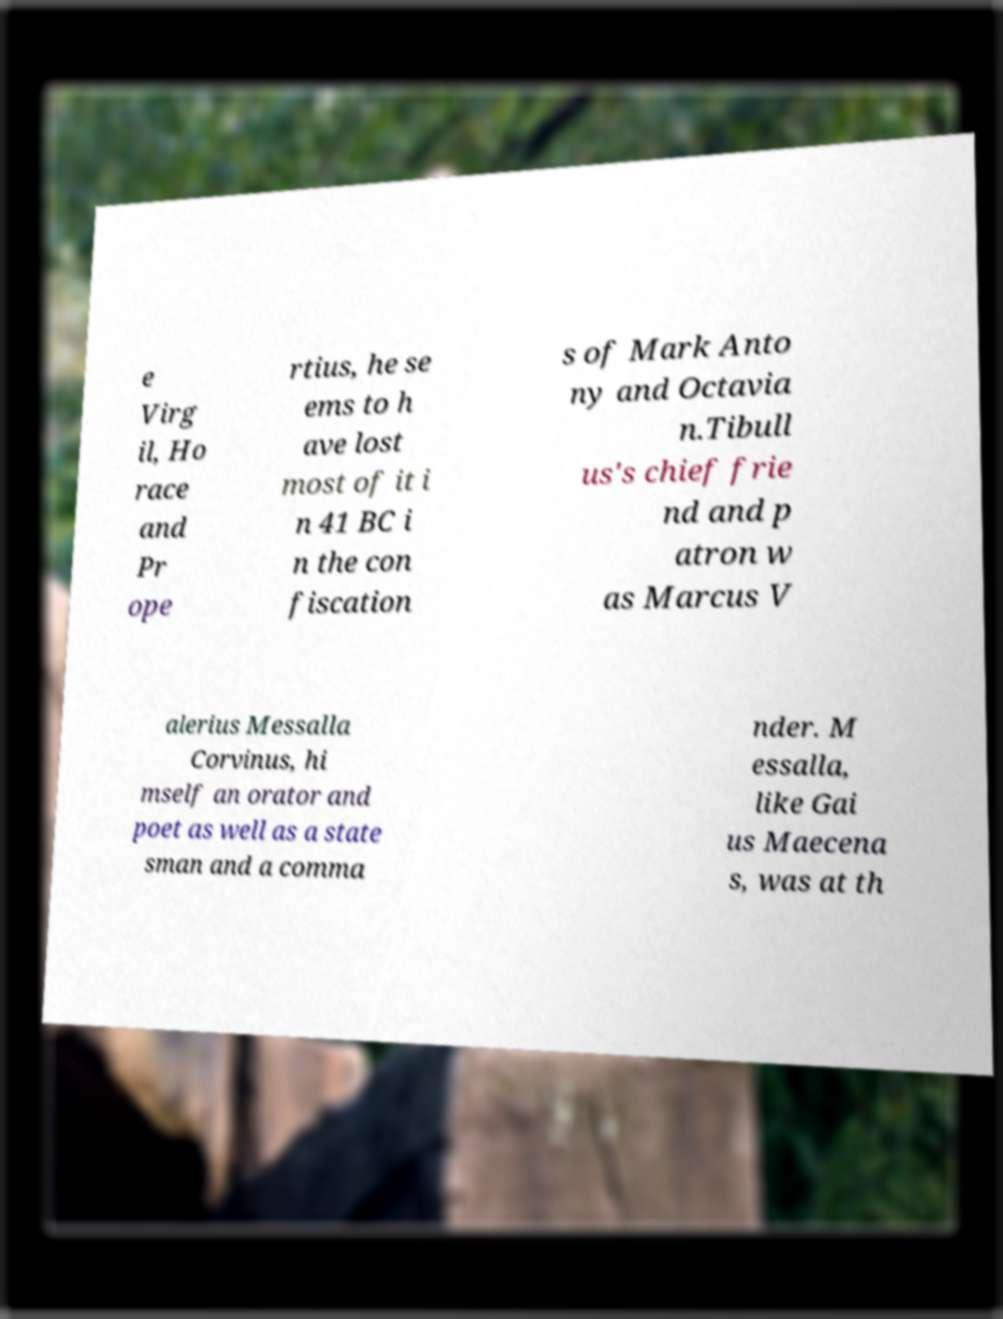What messages or text are displayed in this image? I need them in a readable, typed format. e Virg il, Ho race and Pr ope rtius, he se ems to h ave lost most of it i n 41 BC i n the con fiscation s of Mark Anto ny and Octavia n.Tibull us's chief frie nd and p atron w as Marcus V alerius Messalla Corvinus, hi mself an orator and poet as well as a state sman and a comma nder. M essalla, like Gai us Maecena s, was at th 